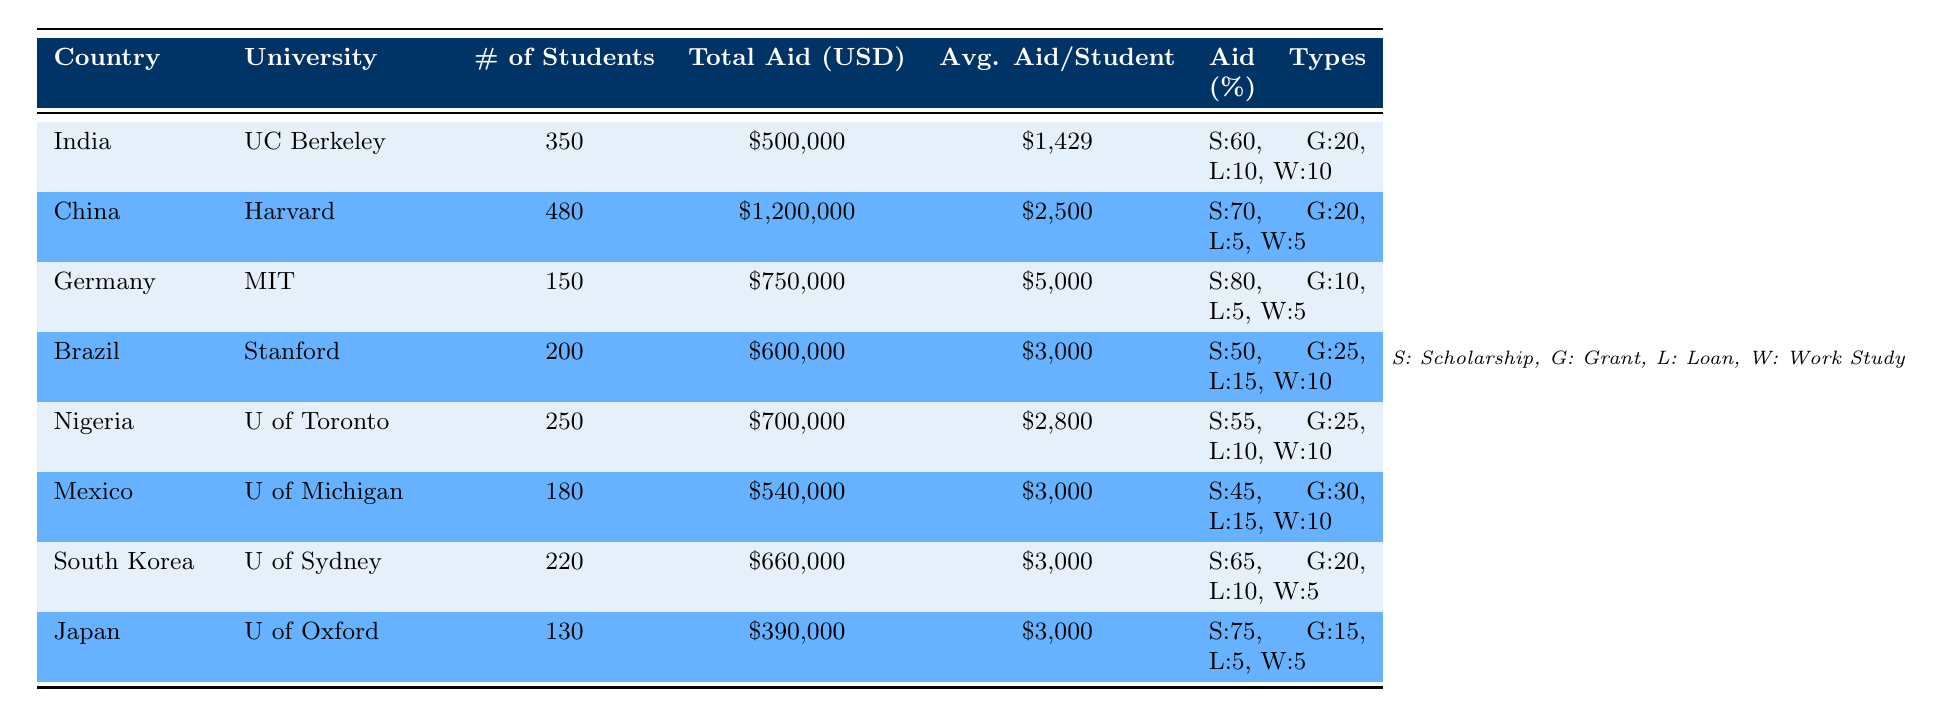What is the total aid awarded to students from China? According to the table, the total aid awarded to students from China is clearly listed as one million two hundred thousand USD.
Answer: 1,200,000 USD Which university has awarded the highest average aid per student? By comparing the average aid per student across all universities, the average aid is highest for students from Germany at 5,000 USD.
Answer: Massachusetts Institute of Technology What percentage of aid types for students from Nigeria are scholarships? For students from Nigeria, scholarships make up 55% of the aid types awarded, as stated in the table.
Answer: 55% How much total aid is awarded to Brazil and South Korea combined? The total aid awarded to Brazil is 600,000 USD, and for South Korea, it is 660,000 USD. Summing these amounts gives 600,000 + 660,000 = 1,260,000 USD.
Answer: 1,260,000 USD Is it true that more students received aid at Harvard University than at the University of California, Berkeley? Harvard University has 480 students receiving aid, while UC Berkeley has 350 students. Since 480 is greater than 350, the statement is true.
Answer: Yes What is the average aid per student for students from Brazil, Nigeria, and Mexico? The average aid per student for Brazil is 3,000 USD, for Nigeria is 2,800 USD, and for Mexico is also 3,000 USD. First, sum these averages: 3,000 + 2,800 + 3,000 = 8,800 USD. There are three groups, so to find the average: 8,800 / 3 = 2,933.33 USD.
Answer: 2,933.33 USD Which country has the smallest number of students receiving financial aid? The data shows that Japan has the smallest number of students receiving aid, with only 130 students listed.
Answer: Japan What types of financial aid are given to Brazilian students? The table specifies that Brazilian students receive 50% scholarships, 25% grants, 15% loans, and 10% work-study aid.
Answer: Scholarships, grants, loans, work-study 